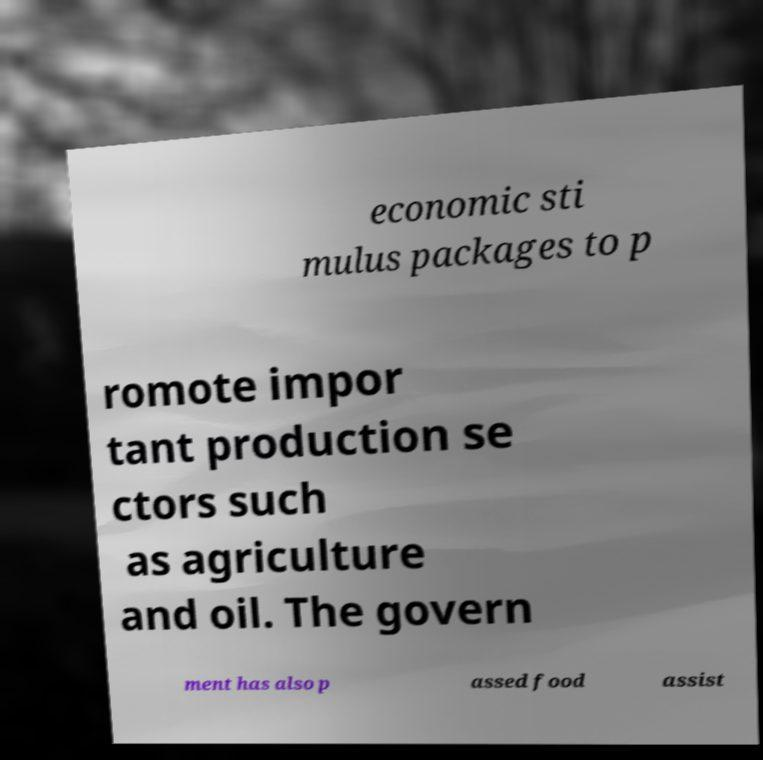Could you extract and type out the text from this image? economic sti mulus packages to p romote impor tant production se ctors such as agriculture and oil. The govern ment has also p assed food assist 